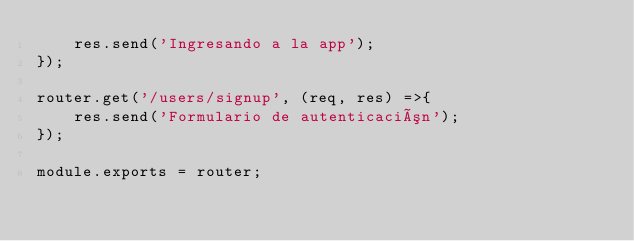Convert code to text. <code><loc_0><loc_0><loc_500><loc_500><_JavaScript_>    res.send('Ingresando a la app');
});

router.get('/users/signup', (req, res) =>{
    res.send('Formulario de autenticación');
});

module.exports = router;</code> 